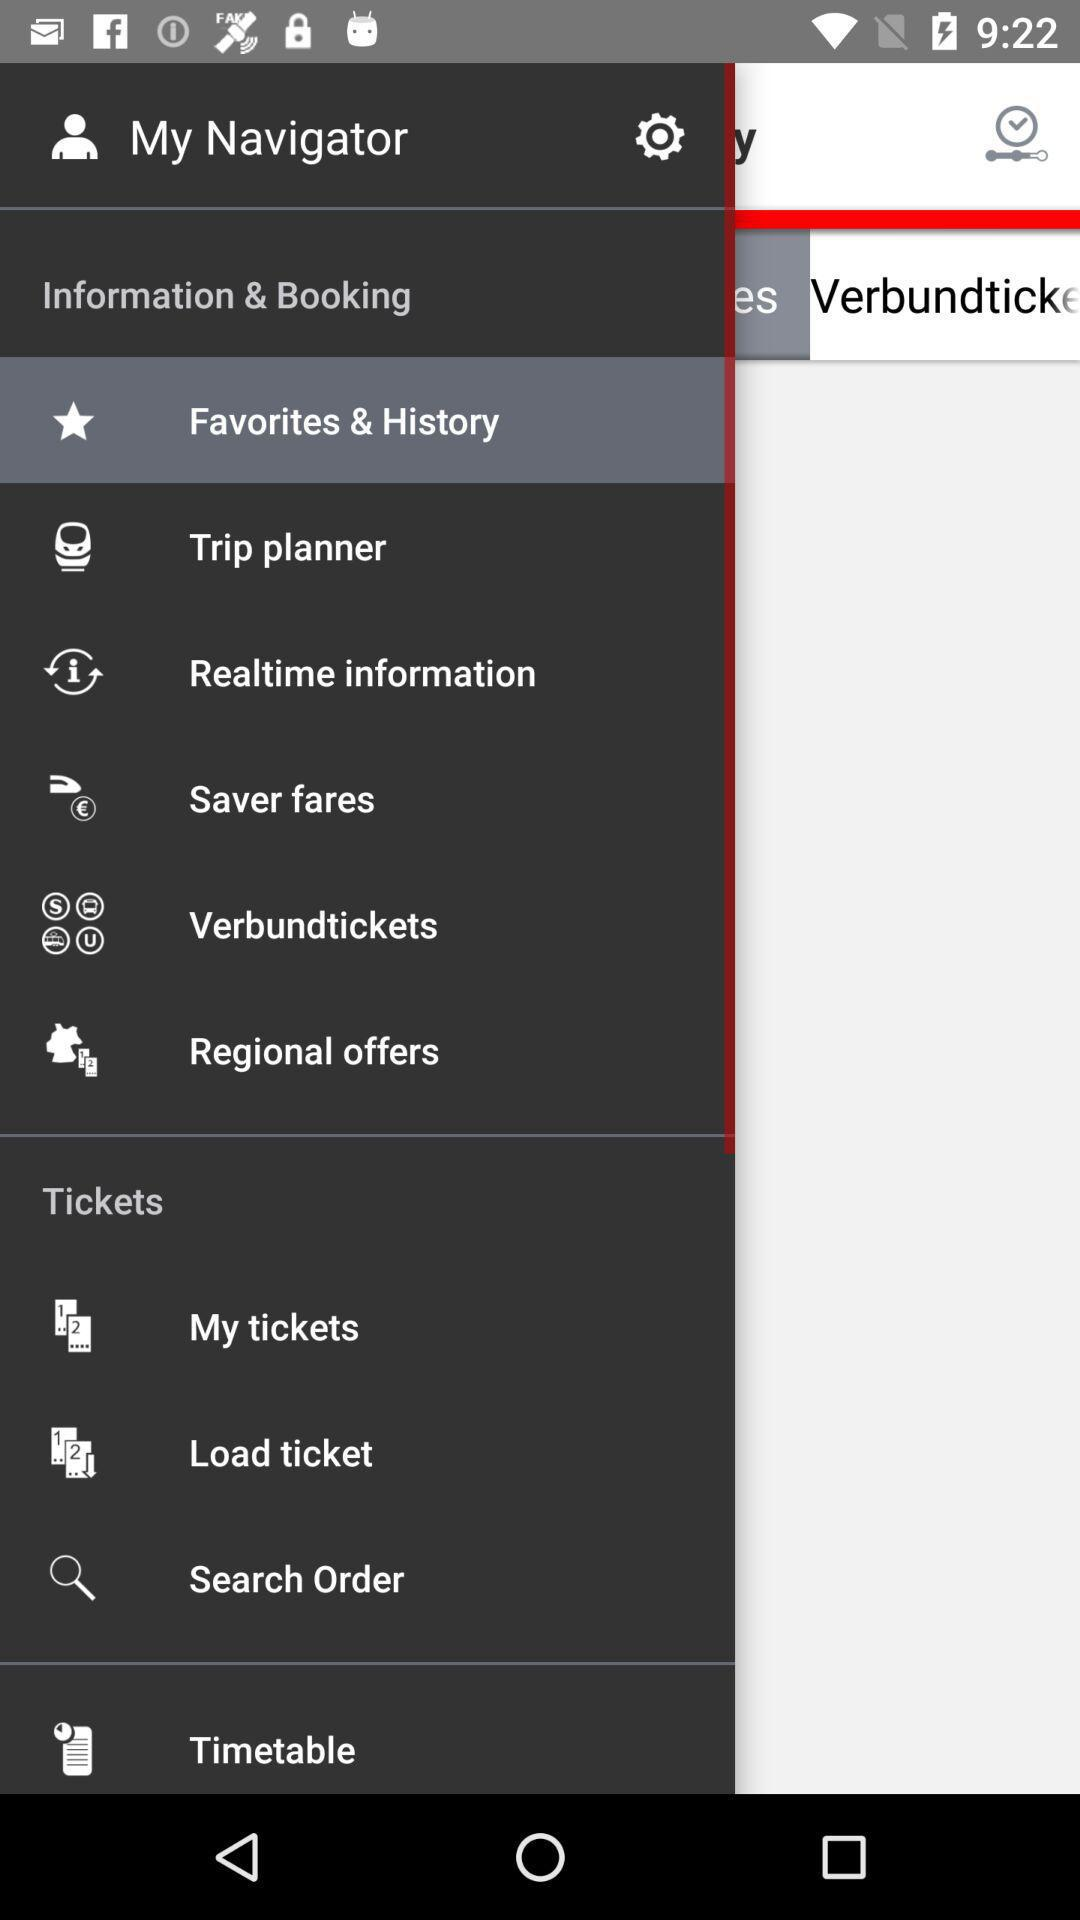Which option is selected? The selected option is "Favorites & History". 